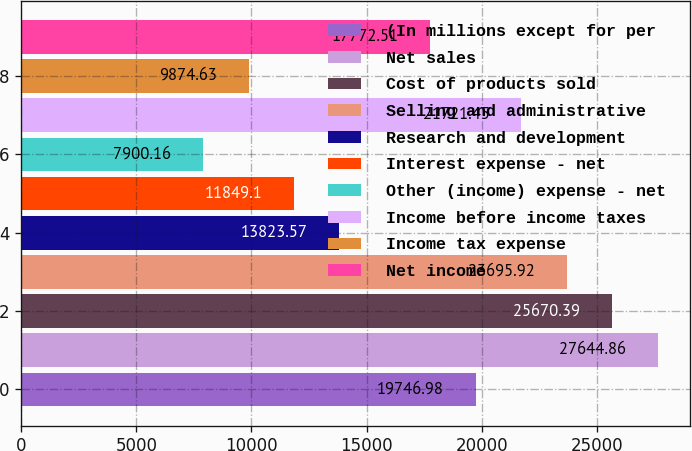<chart> <loc_0><loc_0><loc_500><loc_500><bar_chart><fcel>(In millions except for per<fcel>Net sales<fcel>Cost of products sold<fcel>Selling and administrative<fcel>Research and development<fcel>Interest expense - net<fcel>Other (income) expense - net<fcel>Income before income taxes<fcel>Income tax expense<fcel>Net income<nl><fcel>19747<fcel>27644.9<fcel>25670.4<fcel>23695.9<fcel>13823.6<fcel>11849.1<fcel>7900.16<fcel>21721.5<fcel>9874.63<fcel>17772.5<nl></chart> 